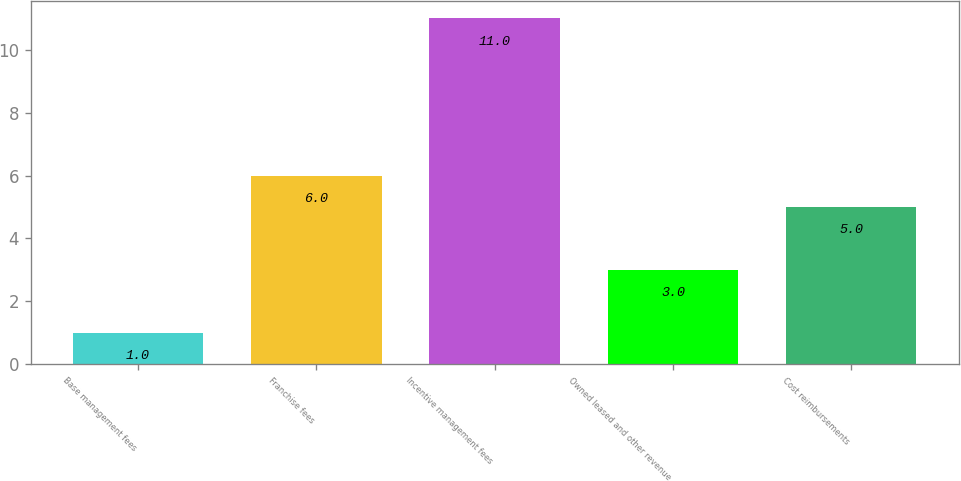Convert chart to OTSL. <chart><loc_0><loc_0><loc_500><loc_500><bar_chart><fcel>Base management fees<fcel>Franchise fees<fcel>Incentive management fees<fcel>Owned leased and other revenue<fcel>Cost reimbursements<nl><fcel>1<fcel>6<fcel>11<fcel>3<fcel>5<nl></chart> 